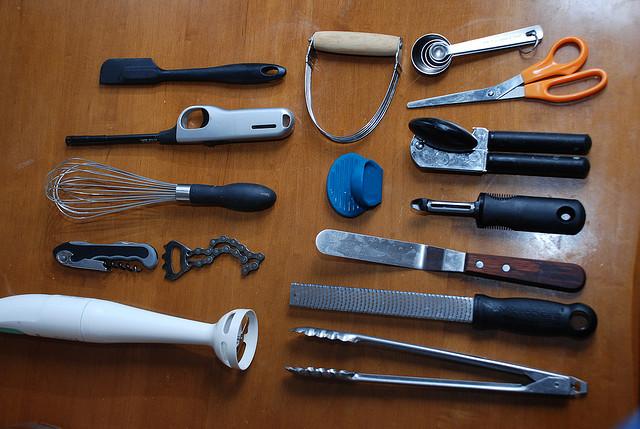Is there a lighter?
Quick response, please. Yes. How many cooking utensils are in the photo?
Quick response, please. 11. What color is the handle of the scissors?
Concise answer only. Orange. 